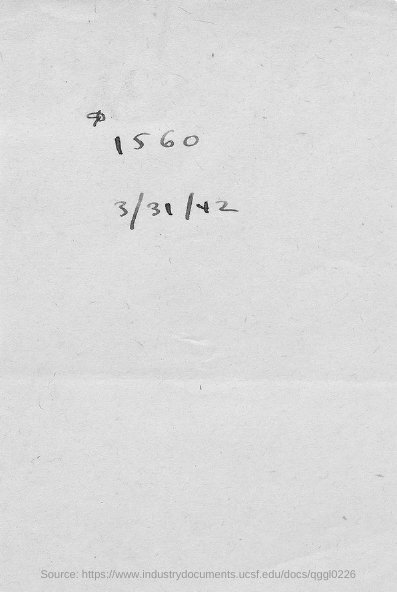Indicate a few pertinent items in this graphic. The document indicates that the date mentioned is March 31, 1942. 